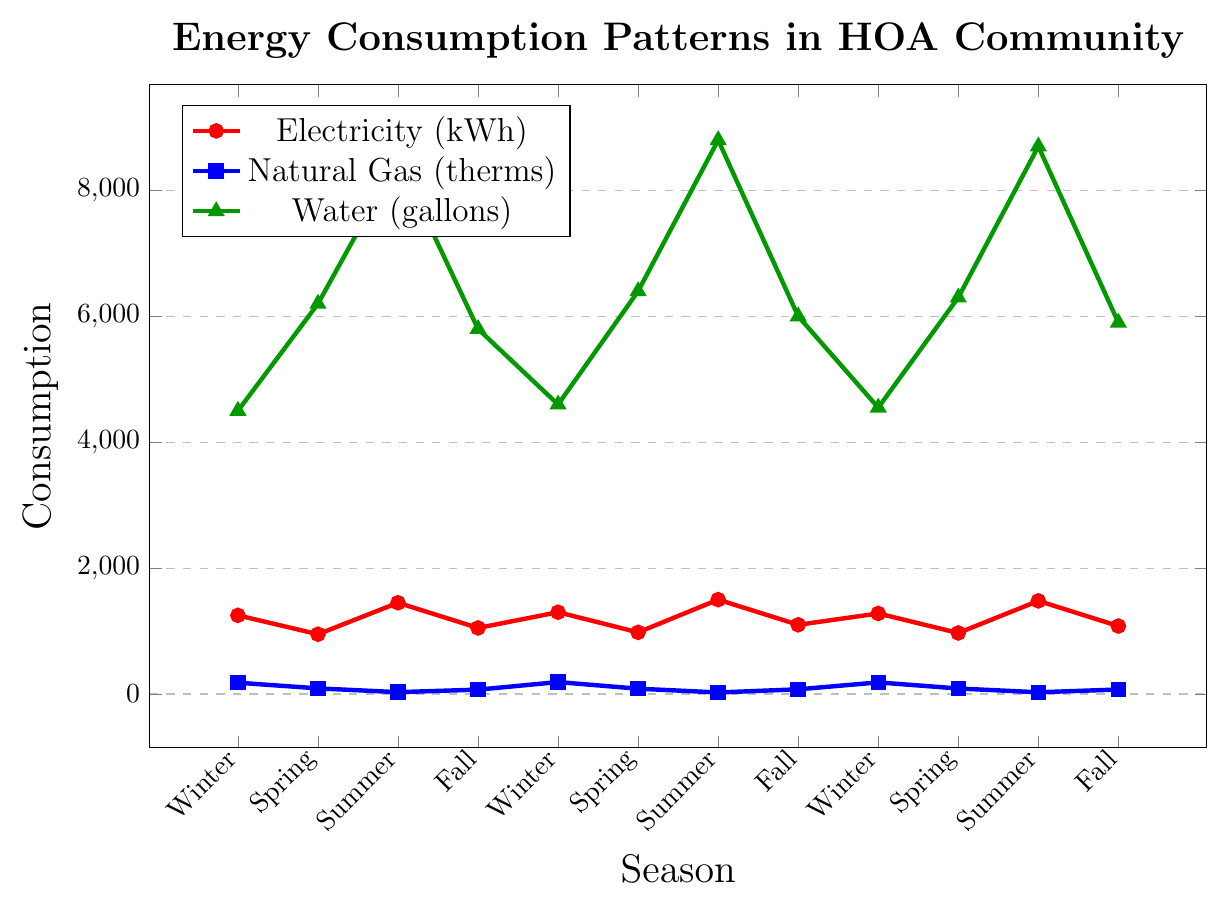what is the average electricity consumption in the summer seasons? To find the average electricity consumption in the summer, we look at the summer data points on the chart: 1450, 1500, and 1480 kWh. Summing these values gives 4430, and dividing by 3 (the number of summer seasons) gives 4430/3 = 1476.67
Answer: 1476.67 In which season does natural gas consumption show the most substantial decrease compared to the previous season? To determine this, we compare the natural gas consumption across sequential seasons. The significant decreases are from Winter (180) to Spring (90), Summer (30) to Fall (70), Winter (190) to Spring (85), Summer (25) to Fall (75), Winter (185) to Spring (88), and Summer (28) to Fall (72). The largest decrease occurs between Winter (180) and Spring (90), a decrease of 90 therms.
Answer: Between Winter and Spring Which utility shows the greatest variability in consumption across the seasons? Comparing the variability visually, water consumption fluctuates the most, going from low values like 4500 gallons in Winter to high values like 8800 gallons in Summer. This is the largest range observed on the chart.
Answer: Water How does the electricity consumption in Fall compare to Natural Gas consumption in Winter? To compare these values, refer to the Fall and Winter points for electricity and natural gas. Electricity in Fall ranges from 1050 to 1100 kWh. Natural Gas in Winter ranges from 180 to 190 therms. Clearly, even the smallest Fall electricity consumption (1050 kWh) is much larger than the highest Winter Natural Gas consumption (190 therms).
Answer: Electricity in Fall is significantly higher than Natural Gas in Winter Is there any season where the consumption of electricity, natural gas, and water simultaneously increases compared to the previous season? To answer this, check data points for simultaneous increases. From Winter to Spring, electricity decreases, but natural gas and water increase. From Spring to Summer, electricity and water increase, but natural gas decreases. From Summer to Fall, electricity and water decrease, and natural gas increases. All scenarios saw only individual increases rather than simultaneous increases of all three utilities.
Answer: No What is the total water consumption for all the Spring seasons combined? The water consumption for Spring seasons are 6200, 6400, and 6300 gallons respectively. Summing these values gives a total of 6200 + 6400 + 6300 = 18900 gallons.
Answer: 18900 During which season does the community consume the least natural gas on average, and what is the average value? We identify the four seasonal data points as follows: Winter(180, 190, 185), Spring(90, 85, 88), Summer(30, 25, 28), and Fall(70, 75, 72). Summer has the lowest values, so we calculate the average therms for Summer: (30 + 25 + 28) / 3 = 83/3 = 27.67 therms.
Answer: Summer, 27.67 What is the difference in electricity consumption between the highest and lowest values recorded? The highest electricity value recorded is 1500 kWh during Summer and the lowest is 950 kWh during Spring. The difference is 1500 - 950 = 550 kWh.
Answer: 550 In the given data, which season shows the highest water consumption? Looking at the water consumption values, the highest value is observed in the Summer season with 8800 gallons.
Answer: Summer 